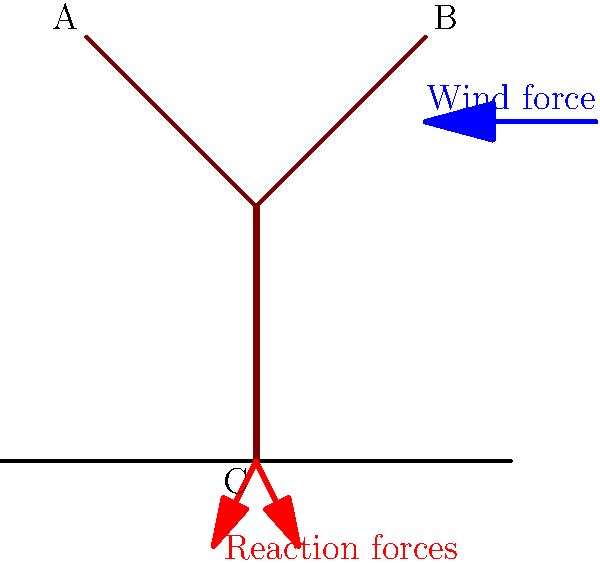Consider an olive tree subjected to a strong wind load as shown in the simplified diagram. The wind force acts horizontally on the tree's canopy, causing the branches to deflect. If the wind force is 500 N and the angle between each branch and the vertical trunk is 45°, what is the axial force (tension or compression) experienced by branch AB? To solve this problem, we'll follow these steps:

1) First, we need to determine how the wind force is distributed between the two branches. Given the symmetry of the tree, we can assume that each branch bears half of the total wind force.

   Force on each branch = 500 N / 2 = 250 N

2) Now, we need to resolve this force into components parallel and perpendicular to the branch. The force parallel to the branch (axial force) is what we're looking for.

3) The angle between the branch and the horizontal is 45°. Therefore, the angle between the wind force (horizontal) and the branch is also 45°.

4) We can use trigonometry to find the axial force:

   Axial force = Wind force on branch × cos(45°)

5) cos(45°) = $\frac{1}{\sqrt{2}} ≈ 0.707$

6) Therefore:
   Axial force = 250 N × 0.707 = 176.8 N

7) The force is compressive because the wind is pushing the branch towards the trunk.
Answer: 176.8 N (compression) 